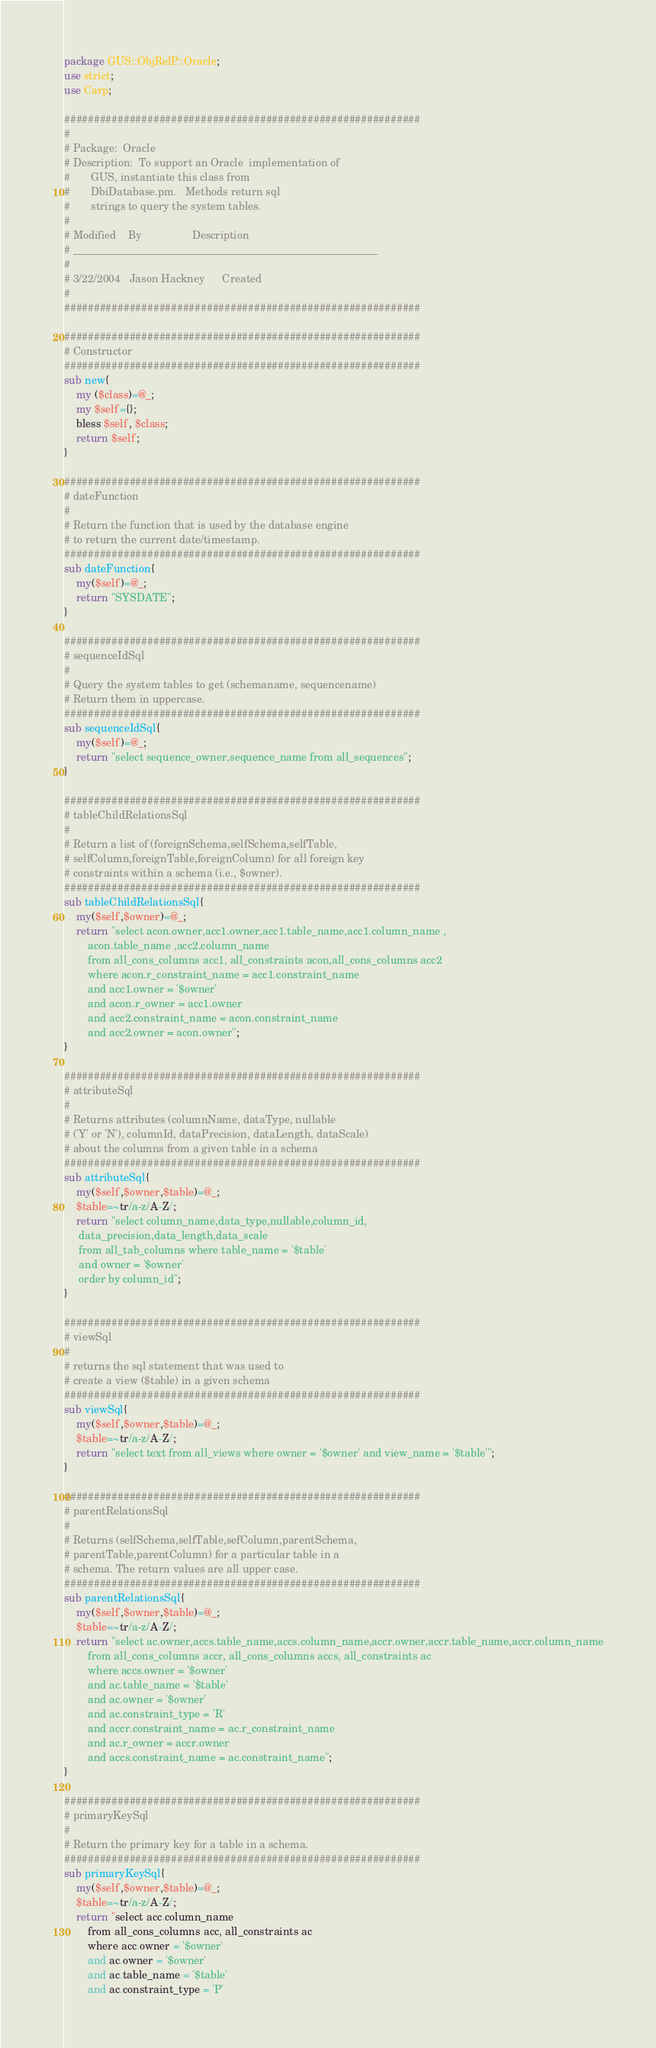<code> <loc_0><loc_0><loc_500><loc_500><_Perl_>package GUS::ObjRelP::Oracle;
use strict;
use Carp;

############################################################
#
# Package:	Oracle
# Description:	To support an Oracle  implementation of 
#		GUS, instantiate this class from 
#		DbiDatabase.pm.   Methods return sql
#		strings to query the system tables.
#
# Modified    By                 Description
# _________________________________________________________
#
# 3/22/2004   Jason Hackney      Created
#
############################################################

############################################################
# Constructor
############################################################
sub new{
	my ($class)=@_;
	my $self={};
	bless $self, $class;
	return $self;
}

############################################################
# dateFunction
#
# Return the function that is used by the database engine 
# to return the current date/timestamp.
############################################################
sub dateFunction{
	my($self)=@_;
	return "SYSDATE";
}

############################################################
# sequenceIdSql
#
# Query the system tables to get (schemaname, sequencename) 
# Return them in uppercase.
############################################################
sub sequenceIdSql{
	my($self)=@_;
	return "select sequence_owner,sequence_name from all_sequences";
}

############################################################
# tableChildRelationsSql
#
# Return a list of (foreignSchema,selfSchema,selfTable,
# selfColumn,foreignTable,foreignColumn) for all foreign key 
# constraints within a schema (i.e., $owner).
############################################################
sub tableChildRelationsSql{
	my($self,$owner)=@_;
	return "select acon.owner,acc1.owner,acc1.table_name,acc1.column_name ,
        acon.table_name ,acc2.column_name 
        from all_cons_columns acc1, all_constraints acon,all_cons_columns acc2
        where acon.r_constraint_name = acc1.constraint_name
        and acc1.owner = '$owner'
        and acon.r_owner = acc1.owner
        and acc2.constraint_name = acon.constraint_name
        and acc2.owner = acon.owner";
}

############################################################
# attributeSql
#
# Returns attributes (columnName, dataType, nullable
# ('Y' or 'N'), columnId, dataPrecision, dataLength, dataScale)
# about the columns from a given table in a schema
############################################################
sub attributeSql{
	my($self,$owner,$table)=@_;
	$table=~tr/a-z/A-Z/;	
	return "select column_name,data_type,nullable,column_id,
     data_precision,data_length,data_scale
     from all_tab_columns where table_name = '$table'
     and owner = '$owner'
     order by column_id";
}

############################################################
# viewSql
#
# returns the sql statement that was used to 
# create a view ($table) in a given schema
############################################################
sub viewSql{
	my($self,$owner,$table)=@_;
	$table=~tr/a-z/A-Z/;
	return "select text from all_views where owner = '$owner' and view_name = '$table'";
}

############################################################
# parentRelationsSql
#
# Returns (selfSchema,selfTable,sefColumn,parentSchema,
# parentTable,parentColumn) for a particular table in a 
# schema. The return values are all upper case.
############################################################
sub parentRelationsSql{
	my($self,$owner,$table)=@_;
	$table=~tr/a-z/A-Z/;
	return "select ac.owner,accs.table_name,accs.column_name,accr.owner,accr.table_name,accr.column_name
        from all_cons_columns accr, all_cons_columns accs, all_constraints ac 
        where accs.owner = '$owner'
        and ac.table_name = '$table'
        and ac.owner = '$owner'
        and ac.constraint_type = 'R'
        and accr.constraint_name = ac.r_constraint_name
        and ac.r_owner = accr.owner
        and accs.constraint_name = ac.constraint_name";
}

############################################################
# primaryKeySql
#
# Return the primary key for a table in a schema.
############################################################
sub primaryKeySql{
	my($self,$owner,$table)=@_;
	$table=~tr/a-z/A-Z/;
	return "select acc.column_name
        from all_cons_columns acc, all_constraints ac
        where acc.owner = '$owner'
        and ac.owner = '$owner'
        and ac.table_name = '$table'
        and ac.constraint_type = 'P'</code> 